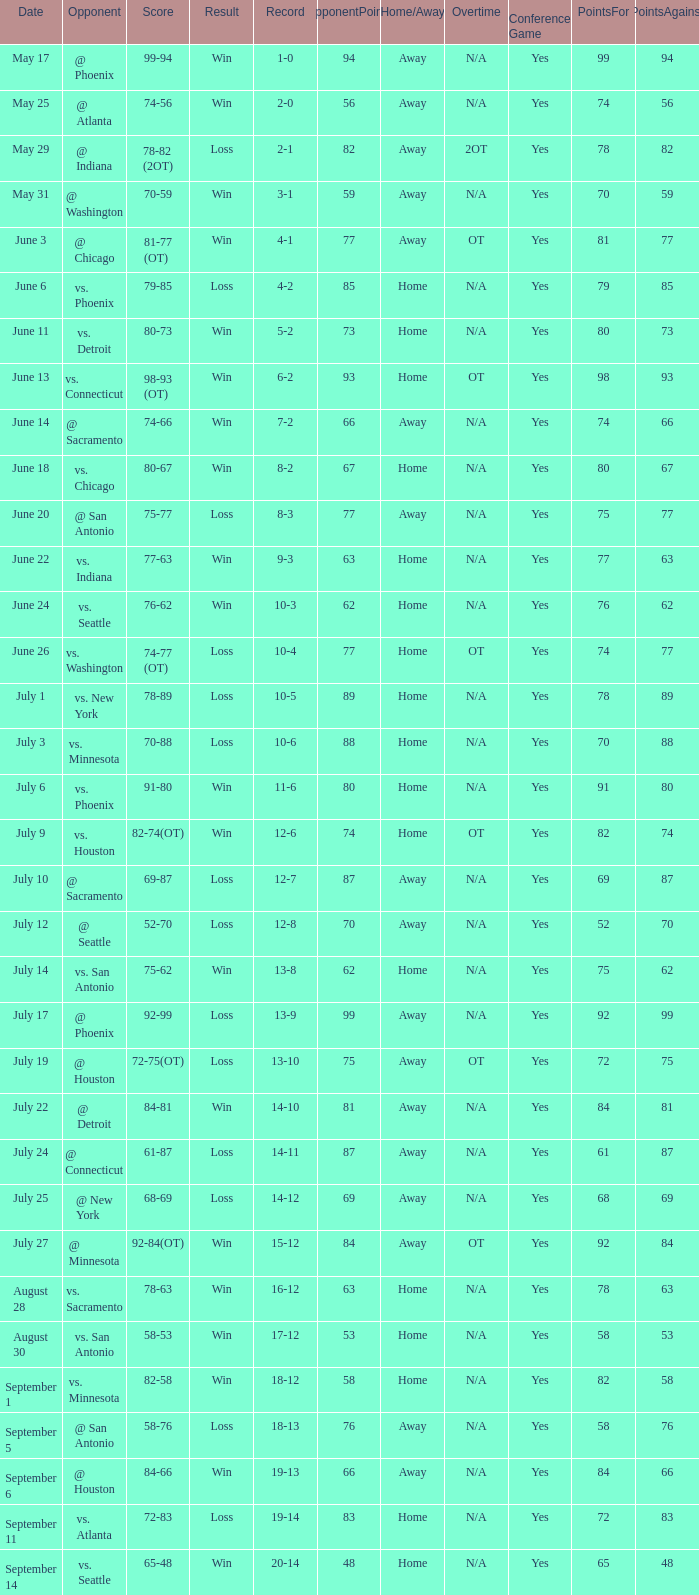What is the Record of the game on September 6? 19-13. 